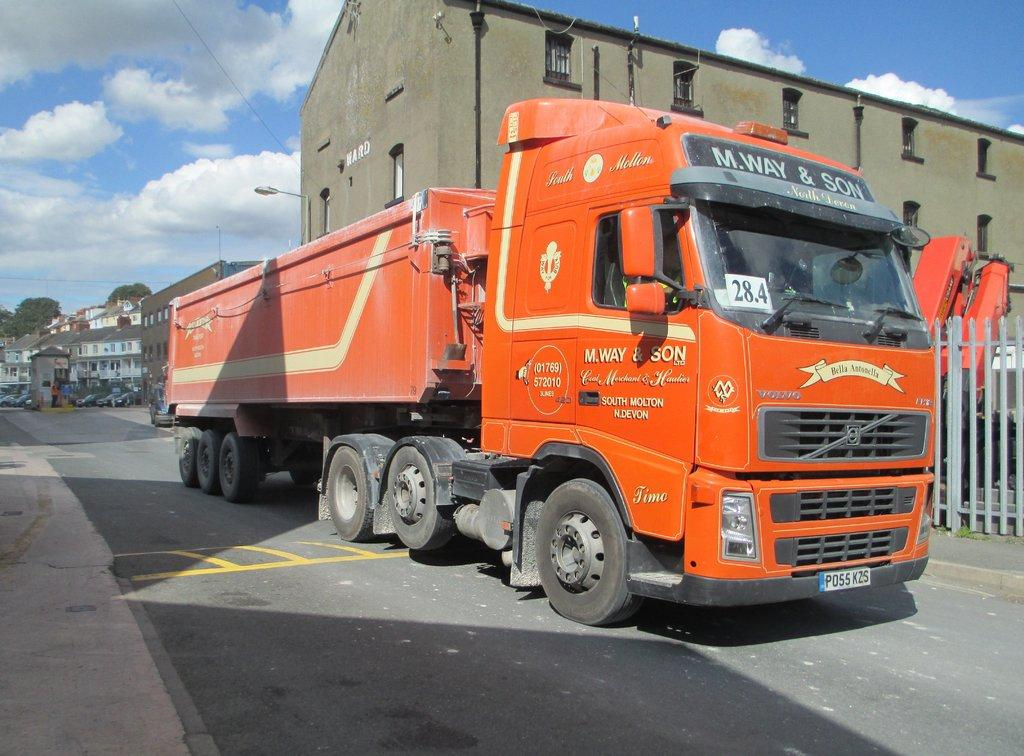What is the main subject of the image? There is a vehicle on the road in the image. What can be seen near the vehicle? There is a fence in the image. What is visible in the background of the image? Buildings, light, trees, vehicles, and the sky are visible in the background of the image. What is the condition of the sky in the image? Clouds are present in the sky. How many people are in the group holding brushes in the image? There is no group holding brushes present in the image. 